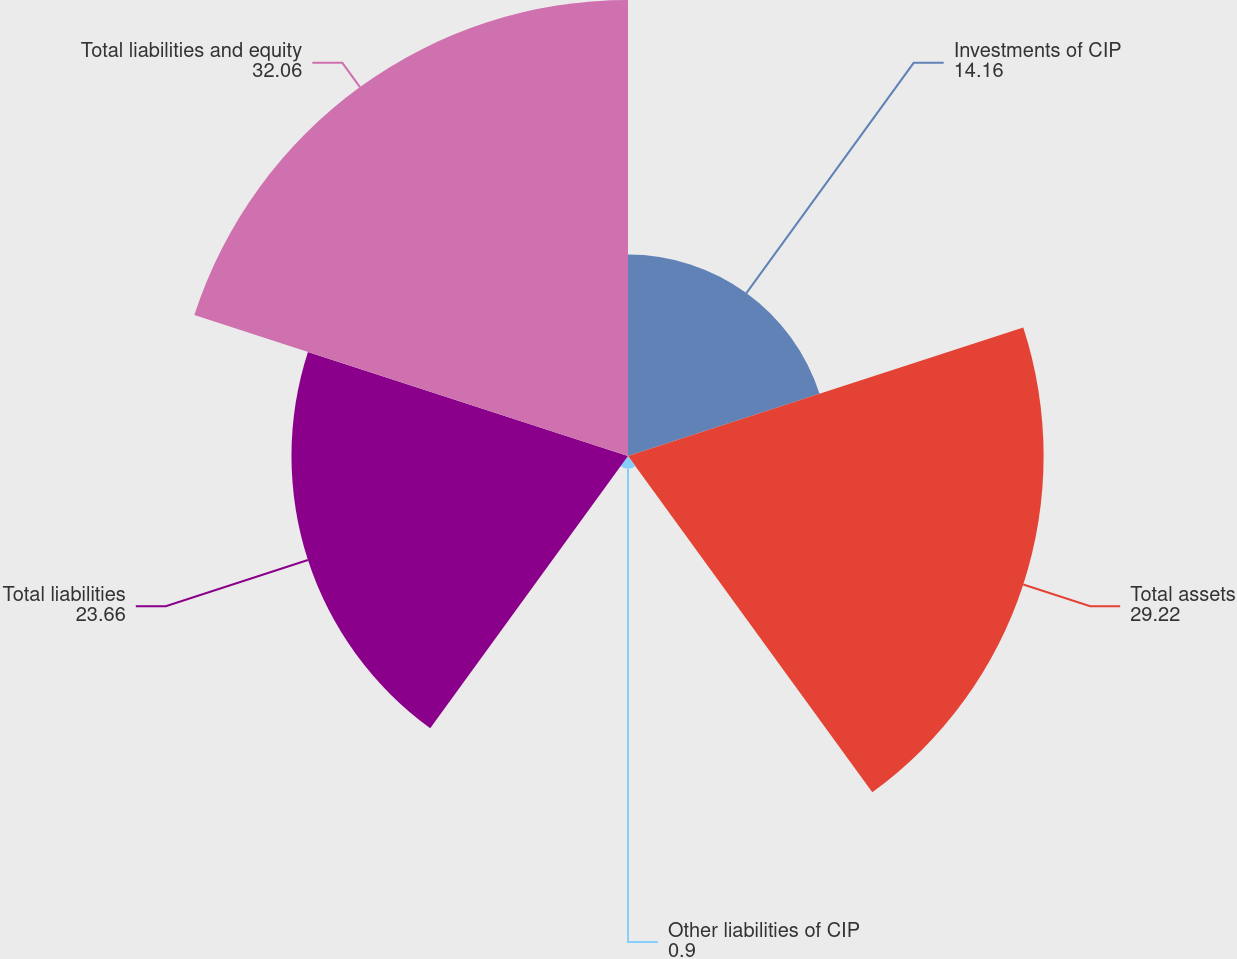<chart> <loc_0><loc_0><loc_500><loc_500><pie_chart><fcel>Investments of CIP<fcel>Total assets<fcel>Other liabilities of CIP<fcel>Total liabilities<fcel>Total liabilities and equity<nl><fcel>14.16%<fcel>29.22%<fcel>0.9%<fcel>23.66%<fcel>32.06%<nl></chart> 